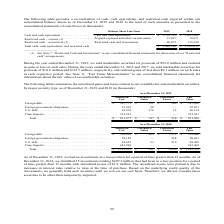According to First Solar's financial document, What amount of marketable securities were sold in 2019? During the year ended December 31, 2019, we sold marketable securities for proceeds of $52.0 million and realized no gain or loss on such sales.. The document states: "During the year ended December 31, 2019, we sold marketable securities for proceeds of $52.0 million and realized no gain or loss on such sales. Durin..." Also, What amount of marketable securities were sold in 2017? According to the financial document, $118.3 million. The relevant text states: "table securities for proceeds of $10.8 million and $118.3 million, respectively, and realized gains of less than $0.1 million on such sales in each respective period..." Also, What is the proceed recognized for the sale of marketable securities in 2018? realized gains of less than $0.1 million on such sales in each respective period. The document states: "0.8 million and $118.3 million, respectively, and realized gains of less than $0.1 million on such sales in each respective period. See Note 11. “Fair..." Also, can you calculate: What percentage of the total cash, cash equivalents, and restricted cash is made up of restricted cash and investments? Based on the calculation: 80,072 / 1,446,510 , the result is 5.54 (percentage). This is based on the information: "noncurrent (1) . Restricted cash and investments 80,072 139,390 Total cash, cash equivalents, and restricted cash $ 1,446,510 $ 1,562,623 tal cash, cash equivalents, and restricted cash $ 1,446,510 $ ..." The key data points involved are: 1,446,510, 80,072. Also, can you calculate: What percentage of the total cash, cash equivalents, and restricted cash is made up of prepaid expenses and other current assets in 2019? Based on the calculation: 13,697 / 1,446,510 , the result is 0.95 (percentage). This is based on the information: "tal cash, cash equivalents, and restricted cash $ 1,446,510 $ 1,562,623 t (1) . Prepaid expenses and other current assets 13,697 19,671..." The key data points involved are: 1,446,510, 13,697. Also, can you calculate: What is the percentage decrease in cash and cash equivalents from 2018 to 2019? To answer this question, I need to perform calculations using the financial data. The calculation is: (1,403,562 - 1,352,741) / 1,403,562 , which equals 3.62 (percentage). This is based on the information: "nd cash equivalents . Cash and cash equivalents $ 1,352,741 $ 1,403,562 valents . Cash and cash equivalents $ 1,352,741 $ 1,403,562..." The key data points involved are: 1,352,741, 1,403,562. 